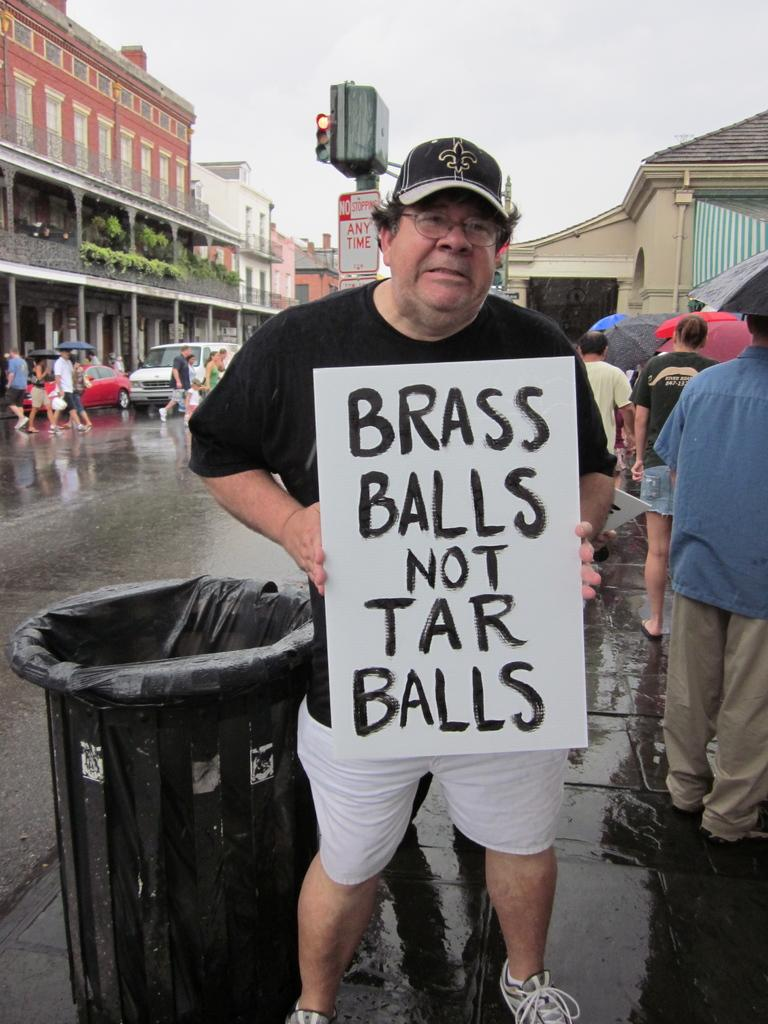Provide a one-sentence caption for the provided image. A man on the side of the street is holding a sign that says brass balls not tar balls. 